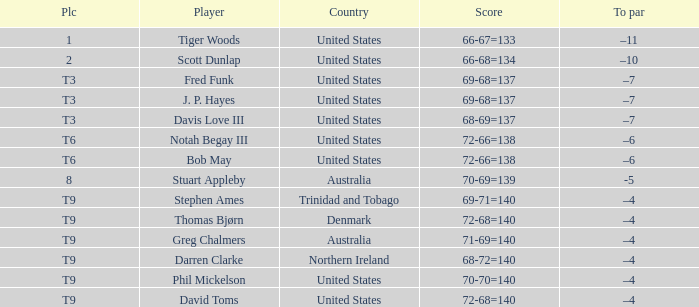What place had a To par of –10? 2.0. Could you parse the entire table? {'header': ['Plc', 'Player', 'Country', 'Score', 'To par'], 'rows': [['1', 'Tiger Woods', 'United States', '66-67=133', '–11'], ['2', 'Scott Dunlap', 'United States', '66-68=134', '–10'], ['T3', 'Fred Funk', 'United States', '69-68=137', '–7'], ['T3', 'J. P. Hayes', 'United States', '69-68=137', '–7'], ['T3', 'Davis Love III', 'United States', '68-69=137', '–7'], ['T6', 'Notah Begay III', 'United States', '72-66=138', '–6'], ['T6', 'Bob May', 'United States', '72-66=138', '–6'], ['8', 'Stuart Appleby', 'Australia', '70-69=139', '-5'], ['T9', 'Stephen Ames', 'Trinidad and Tobago', '69-71=140', '–4'], ['T9', 'Thomas Bjørn', 'Denmark', '72-68=140', '–4'], ['T9', 'Greg Chalmers', 'Australia', '71-69=140', '–4'], ['T9', 'Darren Clarke', 'Northern Ireland', '68-72=140', '–4'], ['T9', 'Phil Mickelson', 'United States', '70-70=140', '–4'], ['T9', 'David Toms', 'United States', '72-68=140', '–4']]} 